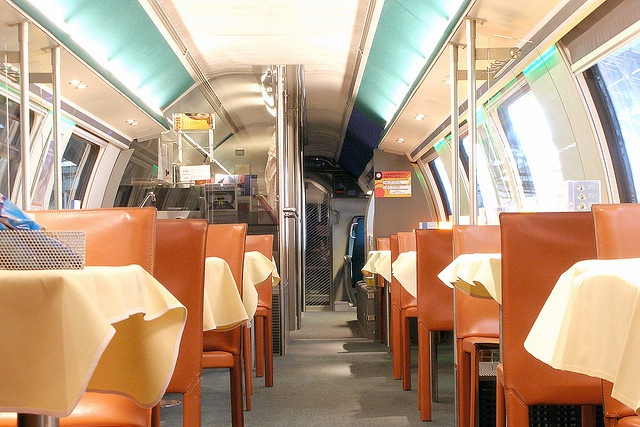Describe the objects in this image and their specific colors. I can see dining table in tan and orange tones, chair in tan, brown, and red tones, dining table in tan and ivory tones, chair in tan, ivory, and red tones, and chair in tan, brown, red, and salmon tones in this image. 